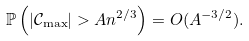Convert formula to latex. <formula><loc_0><loc_0><loc_500><loc_500>\mathbb { P } \left ( | \mathcal { C } _ { \max } | > A n ^ { 2 / 3 } \right ) = O ( A ^ { - 3 / 2 } ) .</formula> 